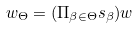Convert formula to latex. <formula><loc_0><loc_0><loc_500><loc_500>w _ { \Theta } = ( \Pi _ { \beta \in \Theta } s _ { \beta } ) w</formula> 